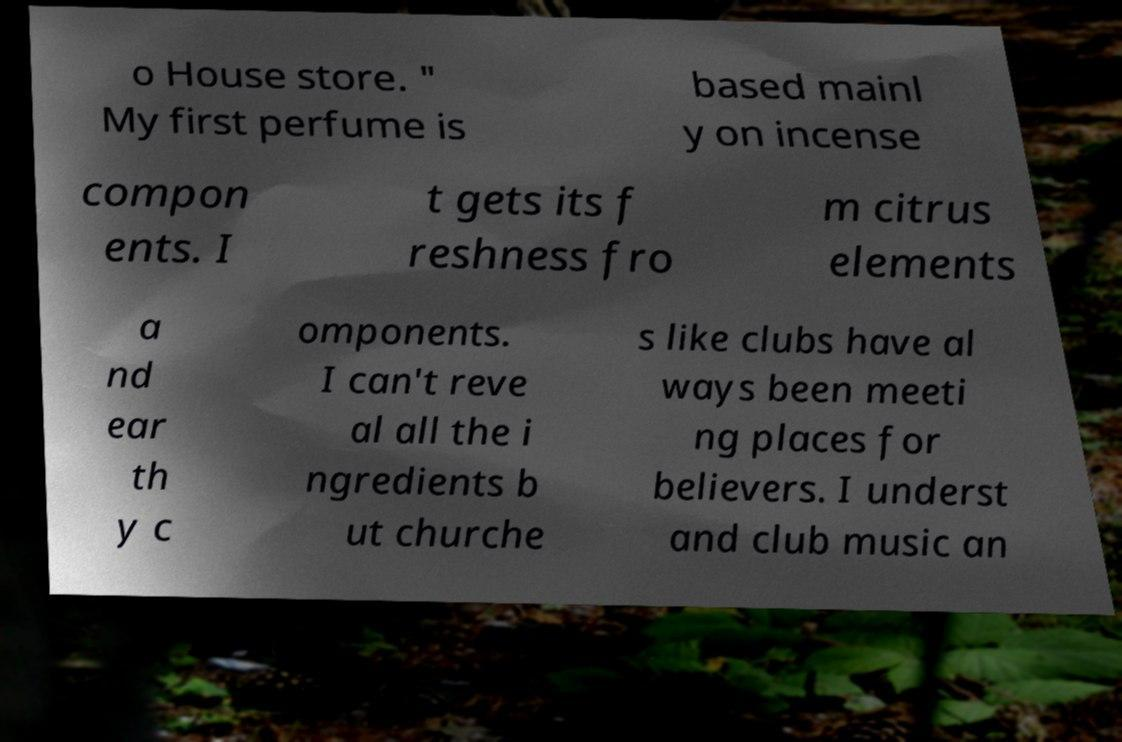Can you read and provide the text displayed in the image?This photo seems to have some interesting text. Can you extract and type it out for me? o House store. " My first perfume is based mainl y on incense compon ents. I t gets its f reshness fro m citrus elements a nd ear th y c omponents. I can't reve al all the i ngredients b ut churche s like clubs have al ways been meeti ng places for believers. I underst and club music an 